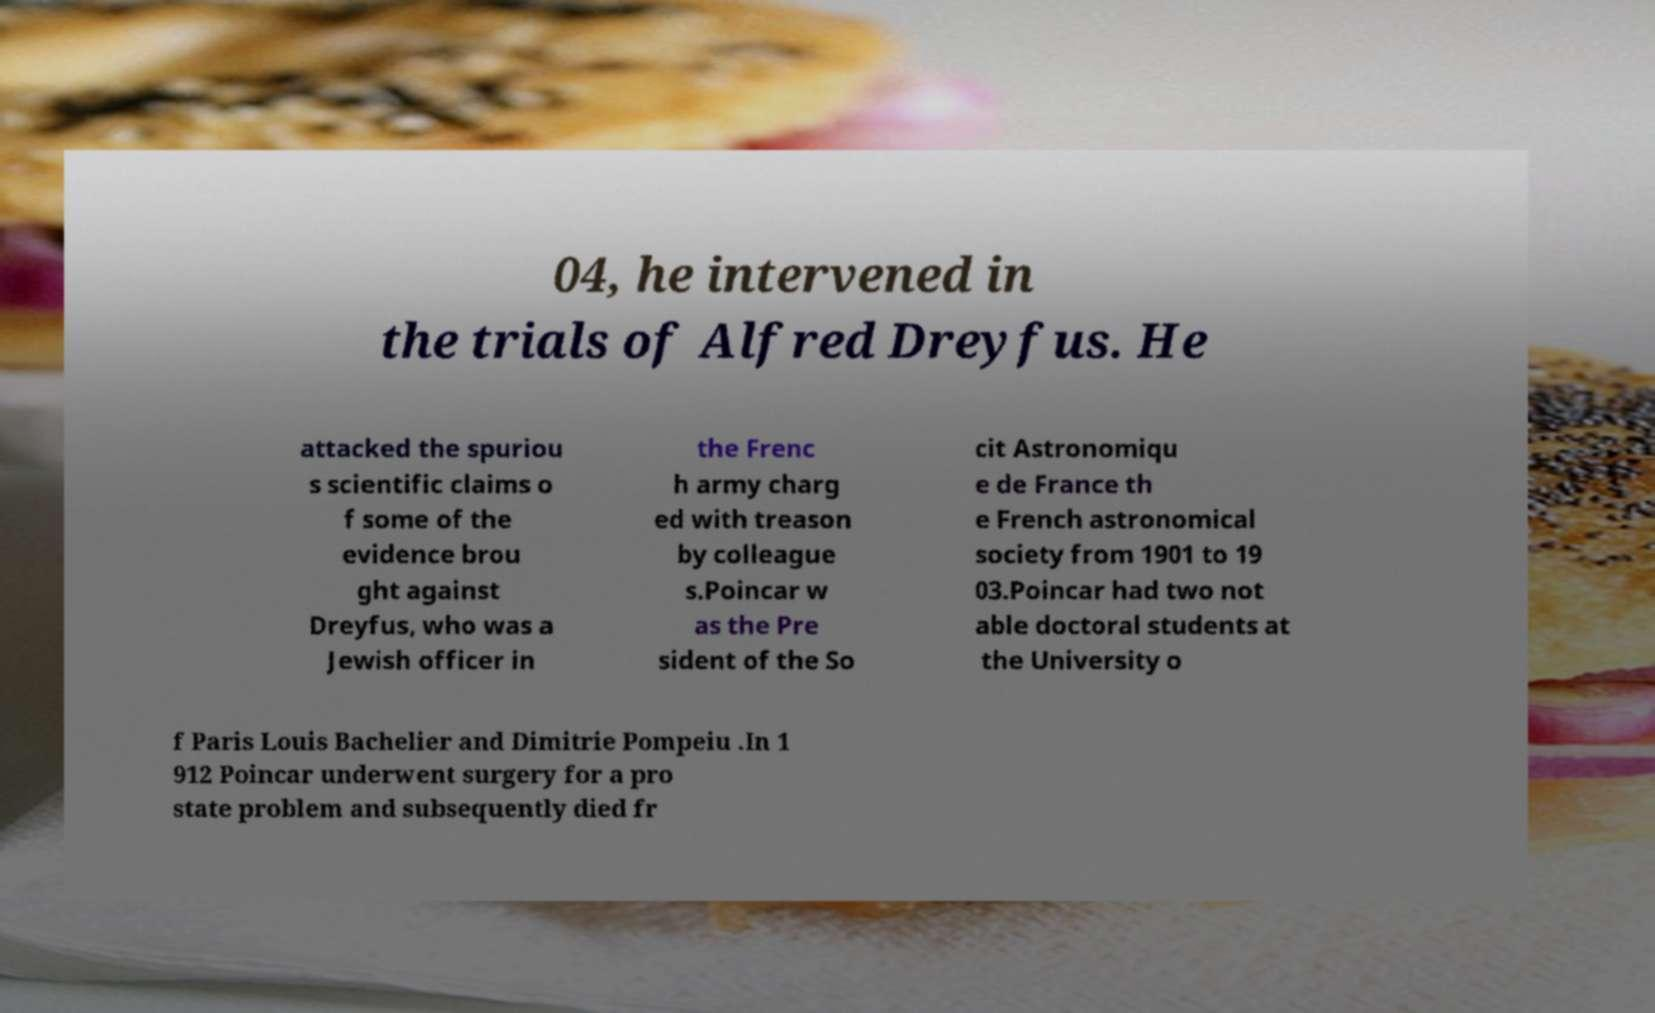For documentation purposes, I need the text within this image transcribed. Could you provide that? 04, he intervened in the trials of Alfred Dreyfus. He attacked the spuriou s scientific claims o f some of the evidence brou ght against Dreyfus, who was a Jewish officer in the Frenc h army charg ed with treason by colleague s.Poincar w as the Pre sident of the So cit Astronomiqu e de France th e French astronomical society from 1901 to 19 03.Poincar had two not able doctoral students at the University o f Paris Louis Bachelier and Dimitrie Pompeiu .In 1 912 Poincar underwent surgery for a pro state problem and subsequently died fr 